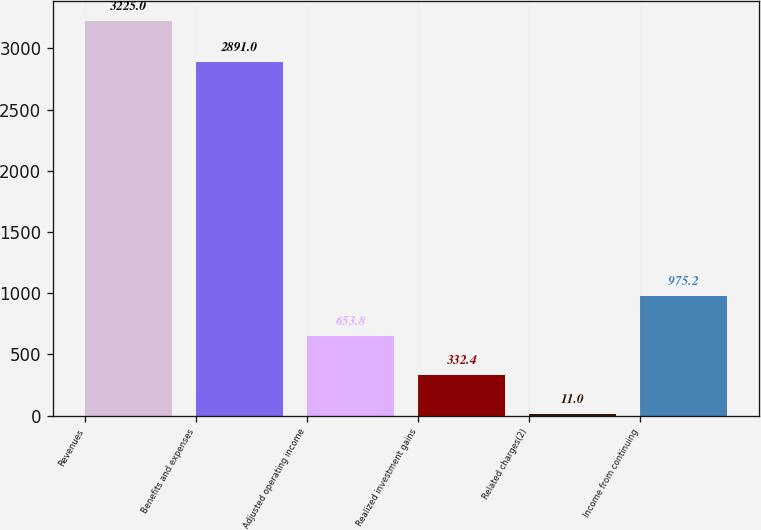<chart> <loc_0><loc_0><loc_500><loc_500><bar_chart><fcel>Revenues<fcel>Benefits and expenses<fcel>Adjusted operating income<fcel>Realized investment gains<fcel>Related charges(2)<fcel>Income from continuing<nl><fcel>3225<fcel>2891<fcel>653.8<fcel>332.4<fcel>11<fcel>975.2<nl></chart> 